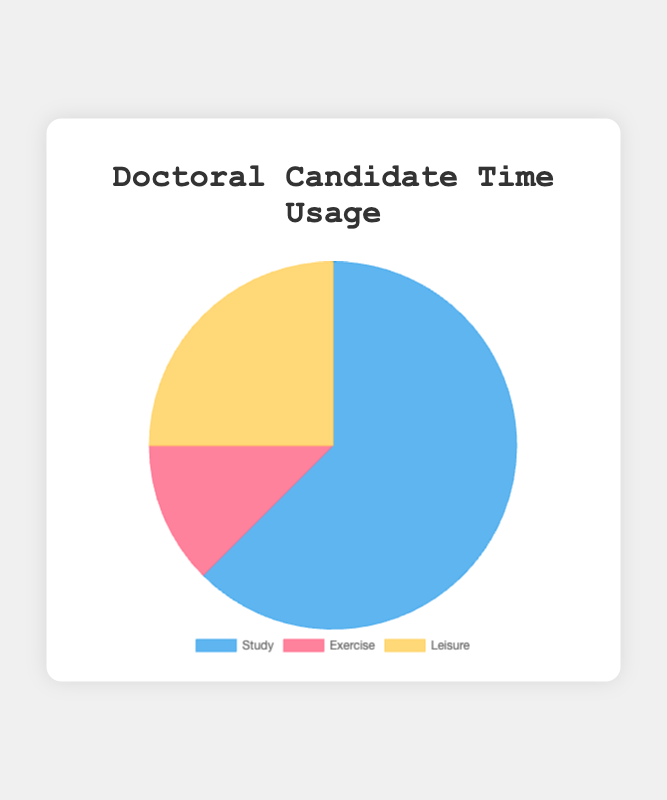What is the total time spent on non-study activities? Add the hours spent on Exercise and Leisure: 2 hours (Exercise) + 4 hours (Leisure) = 6 hours.
Answer: 6 hours What percentage of the day is spent on studying? Calculate the percentage by dividing the study hours by the total hours and multiplying by 100: (10 / (10 + 2 + 4)) * 100 = (10 / 16) * 100 ≈ 62.5%.
Answer: 62.5% Which activity has the least amount of time spent? Compare the duration hours of all activities. Exercise has 2 hours, which is the minimum.
Answer: Exercise How much more time is spent on studying compared to exercise? Subtract the hours spent on exercise from the hours spent on studying: 10 hours (Study) - 2 hours (Exercise) = 8 hours.
Answer: 8 hours What is the ratio of time spent on studying to time spent on leisure? Divide the hours spent on studying by the hours spent on leisure: 10 hours (Study) / 4 hours (Leisure) = 2.5.
Answer: 2.5 If the total daily time is adjusted to 20 hours, keeping proportional time allocation, how many hours will be spent on leisure? First, calculate the proportion of time for leisure in the original total time: 4 hours (Leisure) / 16 hours (Total) = 0.25. Then calculate the new leisure time: 0.25 * 20 hours = 5 hours.
Answer: 5 hours Which activity uses the brightest color in the chart? The brightest color is visually the one most saturated and light, which is yellow used to represent Leisure.
Answer: Leisure What fraction of the total time is used for leisure activities? Compute the fraction by dividing the leisure hours by the total hours: 4 hours (Leisure) / 16 hours (Total) = 1/4.
Answer: 1/4 Is the time spent on exercise more or less than half the time spent on leisure? Compare the exercise time (2 hours) with half the leisure time (4 hours / 2 = 2 hours). The time spent on exercise is equal to half the time spent on leisure.
Answer: Equal to half If an additional 2 hours were spent on leisure, what would be the new total time spent on leisure? Add the additional time to the current leisure time: 4 hours (current) + 2 hours (additional) = 6 hours.
Answer: 6 hours 